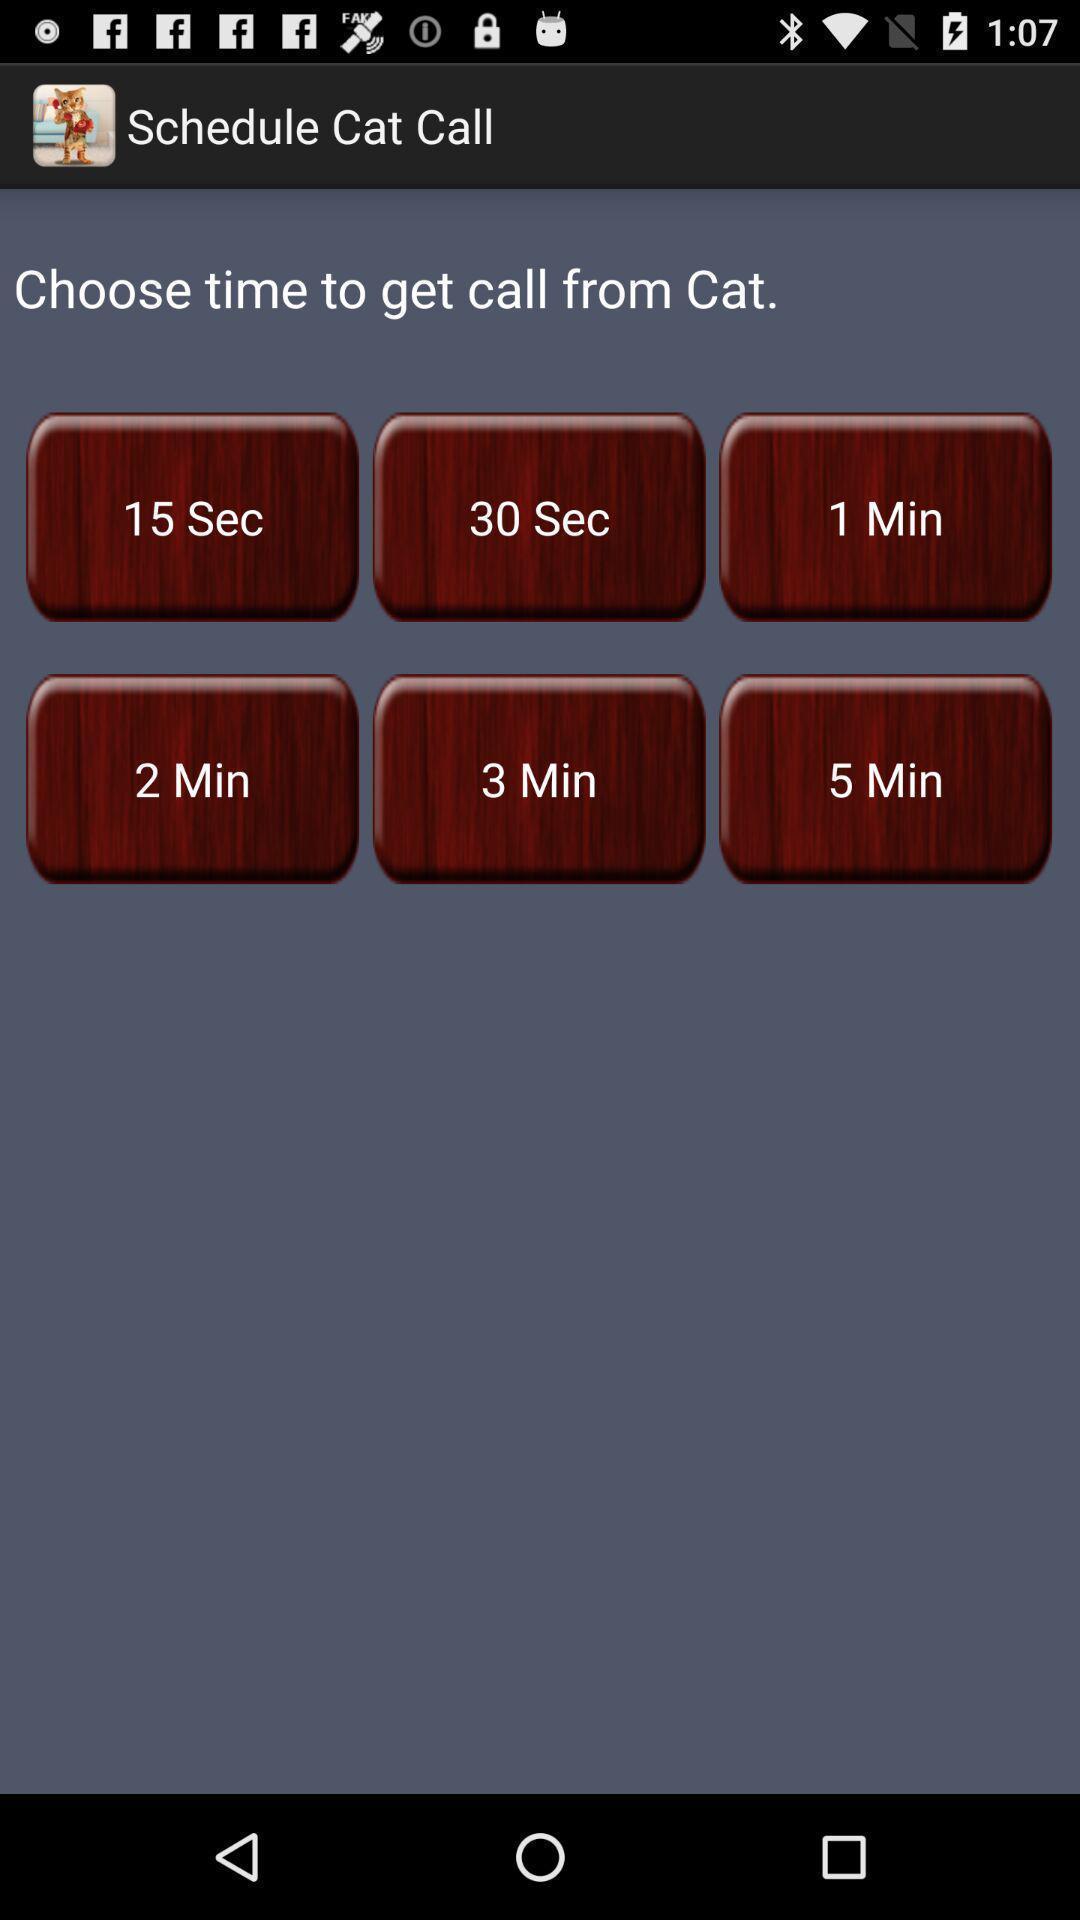What can you discern from this picture? Screen showing various time duration 's of a call scheduler app. 